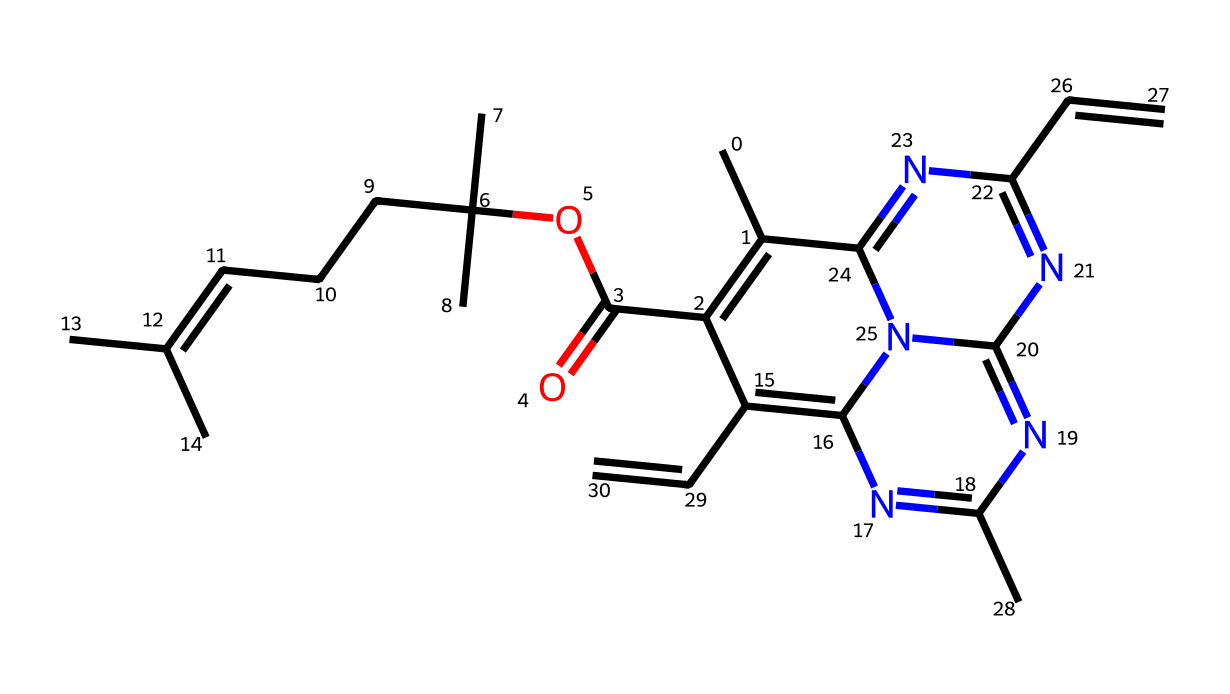What is the molecular formula of this compound? By analyzing the SMILES representation, we can deduce the count of each type of atom. The representation contains carbon (C), hydrogen (H), nitrogen (N), and oxygen (O) atoms. Upon counting, we find there are 24 carbon atoms, 34 hydrogen atoms, 6 nitrogen atoms, and 2 oxygen atoms, leading to the molecular formula C24H34N6O2.
Answer: C24H34N6O2 How many nitrogen atoms are present in this compound? We can identify the presence of nitrogen atoms in the SMILES representation by noting the 'N' symbols. Counting them gives us a total of 6 nitrogen atoms.
Answer: 6 What type of chemical structure is this compound based on its components? The presence of multiple nitrogen atoms and a complex cyclic structure suggests that this compound is a coordination complex. This is typical for compounds that include a metal-indexed coordination center.
Answer: coordination complex What is the primary function of chlorophyll in maple leaves? Chlorophyll primarily functions in the process of photosynthesis by absorbing light, especially in the blue and red wavelengths. Its structure allows it to efficiently capture solar energy.
Answer: photosynthesis How does the presence of nitrogen affect the color change of chlorophyll in leaves? The nitrogen atoms in the chlorophyll structure are integral to maintaining its molecular integrity and stabilization, which affects its ability to absorb light and thus contribute to color change as chlorophyll degrades.
Answer: stability What kind of bonds might be present in this chlorophyll structure? The chemical structure likely contains covalent bonds due to the sharing of electrons between carbon, nitrogen, and oxygen atoms observed in the SMILES. Additionally, there may be coordinate covalent bonds, especially in a coordination compound.
Answer: covalent bonds What role does the ester functional group play in this structure? The ester functional group, represented in the SMILES by the "C(=O)O" part, contributes to the overall stability and reactivity of the molecule, likely impacting how chlorophyll interacts with light and other compounds during color change.
Answer: stability and reactivity 